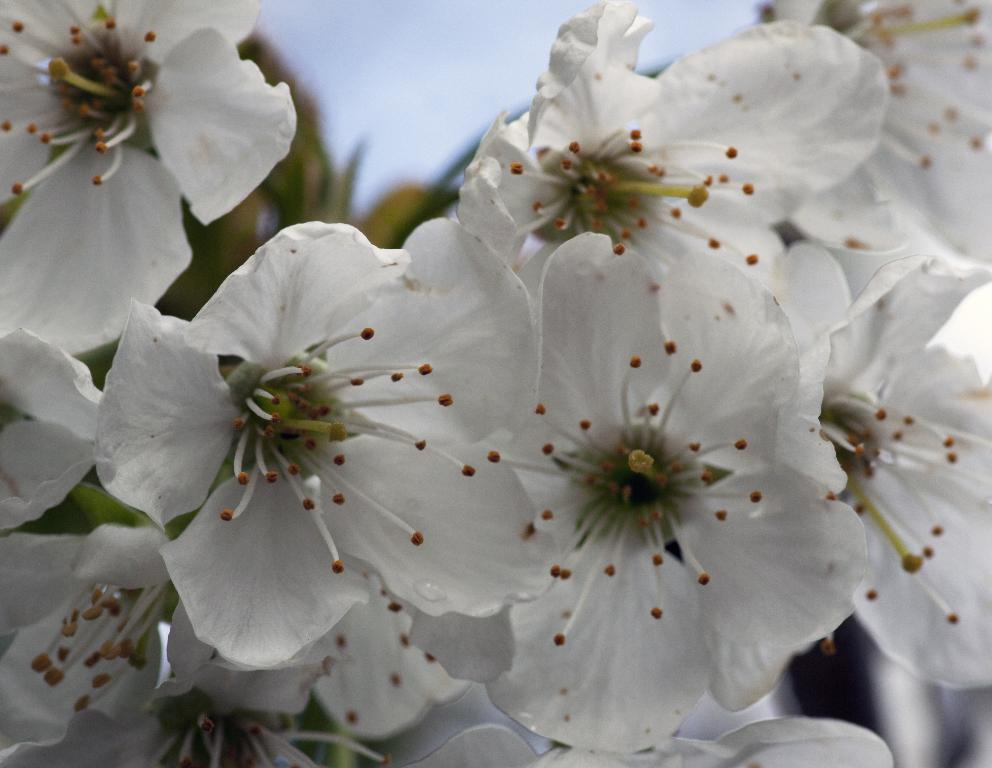What type of flora is present in the image? There are flowers in the image. What colors are the flowers? The flowers are white and yellow in color. What else can be seen in the background of the image? There are plants and the sky visible in the background of the image. How is the background of the image depicted? The background is blurred. Where is the throne located in the image? There is no throne present in the image. What type of milk is being poured over the flowers in the image? There is no milk present in the image; it is a picture of flowers. What level of difficulty is associated with the flowers in the image? The image does not have a level of difficulty associated with it, as it is a still photograph of flowers. 